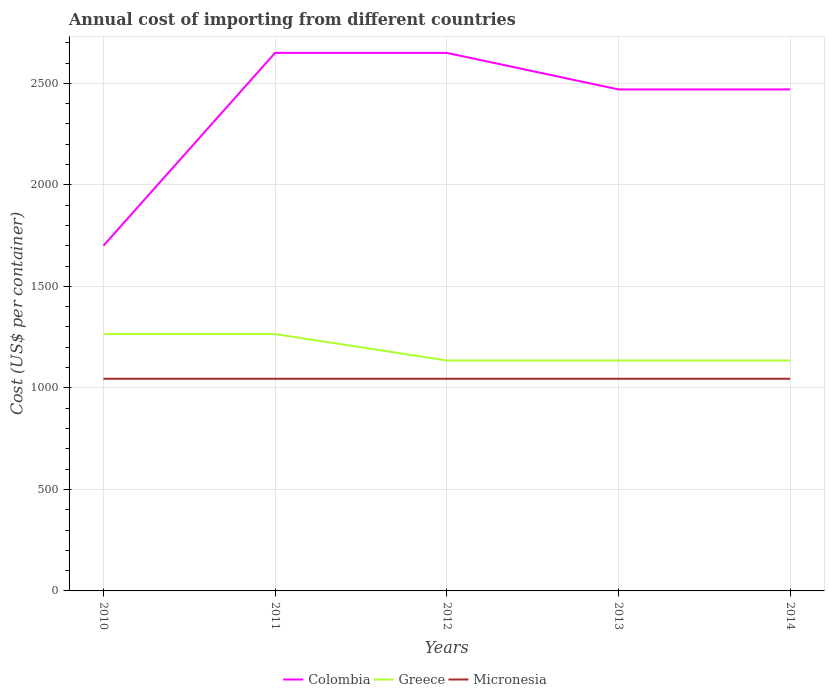Does the line corresponding to Greece intersect with the line corresponding to Colombia?
Your answer should be compact. No. Is the number of lines equal to the number of legend labels?
Give a very brief answer. Yes. Across all years, what is the maximum total annual cost of importing in Colombia?
Keep it short and to the point. 1700. In which year was the total annual cost of importing in Micronesia maximum?
Provide a short and direct response. 2010. What is the total total annual cost of importing in Greece in the graph?
Give a very brief answer. 130. What is the difference between the highest and the second highest total annual cost of importing in Micronesia?
Provide a succinct answer. 0. Is the total annual cost of importing in Greece strictly greater than the total annual cost of importing in Colombia over the years?
Give a very brief answer. Yes. How many lines are there?
Give a very brief answer. 3. How many years are there in the graph?
Keep it short and to the point. 5. What is the difference between two consecutive major ticks on the Y-axis?
Offer a terse response. 500. How many legend labels are there?
Your answer should be compact. 3. How are the legend labels stacked?
Keep it short and to the point. Horizontal. What is the title of the graph?
Your response must be concise. Annual cost of importing from different countries. What is the label or title of the X-axis?
Ensure brevity in your answer.  Years. What is the label or title of the Y-axis?
Your answer should be very brief. Cost (US$ per container). What is the Cost (US$ per container) in Colombia in 2010?
Offer a terse response. 1700. What is the Cost (US$ per container) in Greece in 2010?
Make the answer very short. 1265. What is the Cost (US$ per container) in Micronesia in 2010?
Your response must be concise. 1045. What is the Cost (US$ per container) in Colombia in 2011?
Make the answer very short. 2650. What is the Cost (US$ per container) in Greece in 2011?
Keep it short and to the point. 1265. What is the Cost (US$ per container) in Micronesia in 2011?
Make the answer very short. 1045. What is the Cost (US$ per container) of Colombia in 2012?
Your answer should be very brief. 2650. What is the Cost (US$ per container) of Greece in 2012?
Provide a short and direct response. 1135. What is the Cost (US$ per container) in Micronesia in 2012?
Provide a short and direct response. 1045. What is the Cost (US$ per container) in Colombia in 2013?
Make the answer very short. 2470. What is the Cost (US$ per container) in Greece in 2013?
Your answer should be compact. 1135. What is the Cost (US$ per container) in Micronesia in 2013?
Your answer should be very brief. 1045. What is the Cost (US$ per container) in Colombia in 2014?
Provide a short and direct response. 2470. What is the Cost (US$ per container) in Greece in 2014?
Offer a very short reply. 1135. What is the Cost (US$ per container) of Micronesia in 2014?
Keep it short and to the point. 1045. Across all years, what is the maximum Cost (US$ per container) in Colombia?
Provide a succinct answer. 2650. Across all years, what is the maximum Cost (US$ per container) of Greece?
Ensure brevity in your answer.  1265. Across all years, what is the maximum Cost (US$ per container) of Micronesia?
Your answer should be compact. 1045. Across all years, what is the minimum Cost (US$ per container) of Colombia?
Keep it short and to the point. 1700. Across all years, what is the minimum Cost (US$ per container) in Greece?
Keep it short and to the point. 1135. Across all years, what is the minimum Cost (US$ per container) in Micronesia?
Your answer should be compact. 1045. What is the total Cost (US$ per container) of Colombia in the graph?
Your answer should be very brief. 1.19e+04. What is the total Cost (US$ per container) in Greece in the graph?
Offer a terse response. 5935. What is the total Cost (US$ per container) of Micronesia in the graph?
Make the answer very short. 5225. What is the difference between the Cost (US$ per container) of Colombia in 2010 and that in 2011?
Provide a short and direct response. -950. What is the difference between the Cost (US$ per container) in Micronesia in 2010 and that in 2011?
Keep it short and to the point. 0. What is the difference between the Cost (US$ per container) in Colombia in 2010 and that in 2012?
Give a very brief answer. -950. What is the difference between the Cost (US$ per container) of Greece in 2010 and that in 2012?
Your response must be concise. 130. What is the difference between the Cost (US$ per container) of Colombia in 2010 and that in 2013?
Offer a terse response. -770. What is the difference between the Cost (US$ per container) of Greece in 2010 and that in 2013?
Make the answer very short. 130. What is the difference between the Cost (US$ per container) in Micronesia in 2010 and that in 2013?
Offer a terse response. 0. What is the difference between the Cost (US$ per container) of Colombia in 2010 and that in 2014?
Provide a succinct answer. -770. What is the difference between the Cost (US$ per container) in Greece in 2010 and that in 2014?
Ensure brevity in your answer.  130. What is the difference between the Cost (US$ per container) in Greece in 2011 and that in 2012?
Provide a succinct answer. 130. What is the difference between the Cost (US$ per container) in Micronesia in 2011 and that in 2012?
Give a very brief answer. 0. What is the difference between the Cost (US$ per container) of Colombia in 2011 and that in 2013?
Keep it short and to the point. 180. What is the difference between the Cost (US$ per container) of Greece in 2011 and that in 2013?
Give a very brief answer. 130. What is the difference between the Cost (US$ per container) in Micronesia in 2011 and that in 2013?
Your answer should be very brief. 0. What is the difference between the Cost (US$ per container) in Colombia in 2011 and that in 2014?
Offer a terse response. 180. What is the difference between the Cost (US$ per container) in Greece in 2011 and that in 2014?
Provide a succinct answer. 130. What is the difference between the Cost (US$ per container) in Micronesia in 2011 and that in 2014?
Give a very brief answer. 0. What is the difference between the Cost (US$ per container) in Colombia in 2012 and that in 2013?
Your answer should be compact. 180. What is the difference between the Cost (US$ per container) in Greece in 2012 and that in 2013?
Your answer should be very brief. 0. What is the difference between the Cost (US$ per container) of Colombia in 2012 and that in 2014?
Ensure brevity in your answer.  180. What is the difference between the Cost (US$ per container) of Micronesia in 2012 and that in 2014?
Your answer should be very brief. 0. What is the difference between the Cost (US$ per container) of Colombia in 2013 and that in 2014?
Provide a short and direct response. 0. What is the difference between the Cost (US$ per container) of Greece in 2013 and that in 2014?
Provide a succinct answer. 0. What is the difference between the Cost (US$ per container) in Micronesia in 2013 and that in 2014?
Ensure brevity in your answer.  0. What is the difference between the Cost (US$ per container) of Colombia in 2010 and the Cost (US$ per container) of Greece in 2011?
Give a very brief answer. 435. What is the difference between the Cost (US$ per container) in Colombia in 2010 and the Cost (US$ per container) in Micronesia in 2011?
Ensure brevity in your answer.  655. What is the difference between the Cost (US$ per container) in Greece in 2010 and the Cost (US$ per container) in Micronesia in 2011?
Your response must be concise. 220. What is the difference between the Cost (US$ per container) in Colombia in 2010 and the Cost (US$ per container) in Greece in 2012?
Keep it short and to the point. 565. What is the difference between the Cost (US$ per container) of Colombia in 2010 and the Cost (US$ per container) of Micronesia in 2012?
Offer a very short reply. 655. What is the difference between the Cost (US$ per container) in Greece in 2010 and the Cost (US$ per container) in Micronesia in 2012?
Provide a short and direct response. 220. What is the difference between the Cost (US$ per container) of Colombia in 2010 and the Cost (US$ per container) of Greece in 2013?
Offer a very short reply. 565. What is the difference between the Cost (US$ per container) of Colombia in 2010 and the Cost (US$ per container) of Micronesia in 2013?
Offer a very short reply. 655. What is the difference between the Cost (US$ per container) of Greece in 2010 and the Cost (US$ per container) of Micronesia in 2013?
Provide a succinct answer. 220. What is the difference between the Cost (US$ per container) of Colombia in 2010 and the Cost (US$ per container) of Greece in 2014?
Make the answer very short. 565. What is the difference between the Cost (US$ per container) of Colombia in 2010 and the Cost (US$ per container) of Micronesia in 2014?
Ensure brevity in your answer.  655. What is the difference between the Cost (US$ per container) of Greece in 2010 and the Cost (US$ per container) of Micronesia in 2014?
Ensure brevity in your answer.  220. What is the difference between the Cost (US$ per container) of Colombia in 2011 and the Cost (US$ per container) of Greece in 2012?
Your answer should be compact. 1515. What is the difference between the Cost (US$ per container) in Colombia in 2011 and the Cost (US$ per container) in Micronesia in 2012?
Give a very brief answer. 1605. What is the difference between the Cost (US$ per container) in Greece in 2011 and the Cost (US$ per container) in Micronesia in 2012?
Keep it short and to the point. 220. What is the difference between the Cost (US$ per container) in Colombia in 2011 and the Cost (US$ per container) in Greece in 2013?
Offer a terse response. 1515. What is the difference between the Cost (US$ per container) in Colombia in 2011 and the Cost (US$ per container) in Micronesia in 2013?
Your response must be concise. 1605. What is the difference between the Cost (US$ per container) of Greece in 2011 and the Cost (US$ per container) of Micronesia in 2013?
Make the answer very short. 220. What is the difference between the Cost (US$ per container) of Colombia in 2011 and the Cost (US$ per container) of Greece in 2014?
Provide a succinct answer. 1515. What is the difference between the Cost (US$ per container) of Colombia in 2011 and the Cost (US$ per container) of Micronesia in 2014?
Provide a short and direct response. 1605. What is the difference between the Cost (US$ per container) in Greece in 2011 and the Cost (US$ per container) in Micronesia in 2014?
Make the answer very short. 220. What is the difference between the Cost (US$ per container) in Colombia in 2012 and the Cost (US$ per container) in Greece in 2013?
Keep it short and to the point. 1515. What is the difference between the Cost (US$ per container) of Colombia in 2012 and the Cost (US$ per container) of Micronesia in 2013?
Ensure brevity in your answer.  1605. What is the difference between the Cost (US$ per container) in Greece in 2012 and the Cost (US$ per container) in Micronesia in 2013?
Give a very brief answer. 90. What is the difference between the Cost (US$ per container) of Colombia in 2012 and the Cost (US$ per container) of Greece in 2014?
Make the answer very short. 1515. What is the difference between the Cost (US$ per container) of Colombia in 2012 and the Cost (US$ per container) of Micronesia in 2014?
Make the answer very short. 1605. What is the difference between the Cost (US$ per container) in Colombia in 2013 and the Cost (US$ per container) in Greece in 2014?
Ensure brevity in your answer.  1335. What is the difference between the Cost (US$ per container) in Colombia in 2013 and the Cost (US$ per container) in Micronesia in 2014?
Provide a short and direct response. 1425. What is the difference between the Cost (US$ per container) in Greece in 2013 and the Cost (US$ per container) in Micronesia in 2014?
Provide a short and direct response. 90. What is the average Cost (US$ per container) of Colombia per year?
Give a very brief answer. 2388. What is the average Cost (US$ per container) of Greece per year?
Provide a succinct answer. 1187. What is the average Cost (US$ per container) of Micronesia per year?
Offer a very short reply. 1045. In the year 2010, what is the difference between the Cost (US$ per container) in Colombia and Cost (US$ per container) in Greece?
Your response must be concise. 435. In the year 2010, what is the difference between the Cost (US$ per container) in Colombia and Cost (US$ per container) in Micronesia?
Make the answer very short. 655. In the year 2010, what is the difference between the Cost (US$ per container) in Greece and Cost (US$ per container) in Micronesia?
Ensure brevity in your answer.  220. In the year 2011, what is the difference between the Cost (US$ per container) in Colombia and Cost (US$ per container) in Greece?
Ensure brevity in your answer.  1385. In the year 2011, what is the difference between the Cost (US$ per container) in Colombia and Cost (US$ per container) in Micronesia?
Your answer should be compact. 1605. In the year 2011, what is the difference between the Cost (US$ per container) in Greece and Cost (US$ per container) in Micronesia?
Your answer should be very brief. 220. In the year 2012, what is the difference between the Cost (US$ per container) of Colombia and Cost (US$ per container) of Greece?
Offer a terse response. 1515. In the year 2012, what is the difference between the Cost (US$ per container) in Colombia and Cost (US$ per container) in Micronesia?
Your answer should be compact. 1605. In the year 2013, what is the difference between the Cost (US$ per container) in Colombia and Cost (US$ per container) in Greece?
Your answer should be compact. 1335. In the year 2013, what is the difference between the Cost (US$ per container) in Colombia and Cost (US$ per container) in Micronesia?
Keep it short and to the point. 1425. In the year 2014, what is the difference between the Cost (US$ per container) in Colombia and Cost (US$ per container) in Greece?
Keep it short and to the point. 1335. In the year 2014, what is the difference between the Cost (US$ per container) in Colombia and Cost (US$ per container) in Micronesia?
Make the answer very short. 1425. In the year 2014, what is the difference between the Cost (US$ per container) of Greece and Cost (US$ per container) of Micronesia?
Your response must be concise. 90. What is the ratio of the Cost (US$ per container) of Colombia in 2010 to that in 2011?
Provide a short and direct response. 0.64. What is the ratio of the Cost (US$ per container) in Greece in 2010 to that in 2011?
Offer a very short reply. 1. What is the ratio of the Cost (US$ per container) of Micronesia in 2010 to that in 2011?
Your response must be concise. 1. What is the ratio of the Cost (US$ per container) in Colombia in 2010 to that in 2012?
Ensure brevity in your answer.  0.64. What is the ratio of the Cost (US$ per container) of Greece in 2010 to that in 2012?
Provide a short and direct response. 1.11. What is the ratio of the Cost (US$ per container) of Micronesia in 2010 to that in 2012?
Make the answer very short. 1. What is the ratio of the Cost (US$ per container) of Colombia in 2010 to that in 2013?
Your response must be concise. 0.69. What is the ratio of the Cost (US$ per container) in Greece in 2010 to that in 2013?
Keep it short and to the point. 1.11. What is the ratio of the Cost (US$ per container) in Micronesia in 2010 to that in 2013?
Your response must be concise. 1. What is the ratio of the Cost (US$ per container) of Colombia in 2010 to that in 2014?
Give a very brief answer. 0.69. What is the ratio of the Cost (US$ per container) of Greece in 2010 to that in 2014?
Provide a short and direct response. 1.11. What is the ratio of the Cost (US$ per container) in Colombia in 2011 to that in 2012?
Give a very brief answer. 1. What is the ratio of the Cost (US$ per container) in Greece in 2011 to that in 2012?
Your answer should be compact. 1.11. What is the ratio of the Cost (US$ per container) in Colombia in 2011 to that in 2013?
Offer a terse response. 1.07. What is the ratio of the Cost (US$ per container) of Greece in 2011 to that in 2013?
Offer a very short reply. 1.11. What is the ratio of the Cost (US$ per container) in Colombia in 2011 to that in 2014?
Keep it short and to the point. 1.07. What is the ratio of the Cost (US$ per container) in Greece in 2011 to that in 2014?
Keep it short and to the point. 1.11. What is the ratio of the Cost (US$ per container) of Micronesia in 2011 to that in 2014?
Make the answer very short. 1. What is the ratio of the Cost (US$ per container) of Colombia in 2012 to that in 2013?
Keep it short and to the point. 1.07. What is the ratio of the Cost (US$ per container) in Greece in 2012 to that in 2013?
Make the answer very short. 1. What is the ratio of the Cost (US$ per container) of Colombia in 2012 to that in 2014?
Your answer should be compact. 1.07. What is the ratio of the Cost (US$ per container) of Micronesia in 2012 to that in 2014?
Keep it short and to the point. 1. What is the ratio of the Cost (US$ per container) of Colombia in 2013 to that in 2014?
Your response must be concise. 1. What is the ratio of the Cost (US$ per container) in Micronesia in 2013 to that in 2014?
Your answer should be very brief. 1. What is the difference between the highest and the second highest Cost (US$ per container) of Micronesia?
Offer a terse response. 0. What is the difference between the highest and the lowest Cost (US$ per container) of Colombia?
Keep it short and to the point. 950. What is the difference between the highest and the lowest Cost (US$ per container) of Greece?
Provide a short and direct response. 130. What is the difference between the highest and the lowest Cost (US$ per container) in Micronesia?
Your answer should be very brief. 0. 